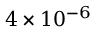Convert formula to latex. <formula><loc_0><loc_0><loc_500><loc_500>4 \times 1 0 ^ { - 6 }</formula> 